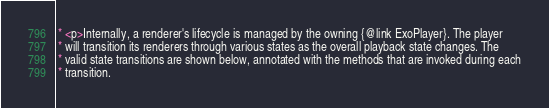Convert code to text. <code><loc_0><loc_0><loc_500><loc_500><_Java_> * <p>Internally, a renderer's lifecycle is managed by the owning {@link ExoPlayer}. The player
 * will transition its renderers through various states as the overall playback state changes. The
 * valid state transitions are shown below, annotated with the methods that are invoked during each
 * transition.</code> 